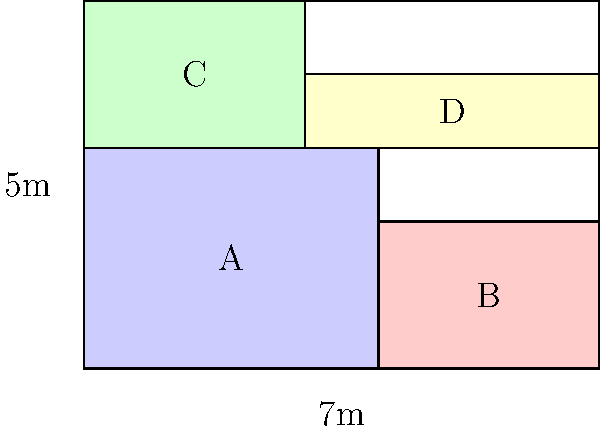Your luxury fashion brand uses high-quality fabric that comes in 7m x 5m rectangles. You need to cut four types of garment pieces: A (4m x 3m), B (3m x 2m), C (3m x 2m), and D (4m x 1m). The profit per piece is €500 for A, €300 for B, €350 for C, and €200 for D. How many pieces of each type should be cut from a single fabric rectangle to maximize profit, and what is the maximum profit? To solve this linear programming problem, we'll follow these steps:

1) Define variables:
   Let $x_A$, $x_B$, $x_C$, and $x_D$ be the number of pieces of each type.

2) Objective function (profit to maximize):
   $P = 500x_A + 300x_B + 350x_C + 200x_D$

3) Constraints:
   a) Area constraint: $12x_A + 6x_B + 6x_C + 4x_D \leq 35$ (total area is 7m x 5m = 35 sq m)
   b) Non-negativity: $x_A, x_B, x_C, x_D \geq 0$ and integers

4) From the diagram, we can see that the maximum possible combinations are:
   - 1A + 1B + 1C + 1D
   - 2A + 1D
   - 1A + 1C + 2D

5) Let's calculate the profit for each combination:
   - 1A + 1B + 1C + 1D: 500 + 300 + 350 + 200 = €1350
   - 2A + 1D: 2(500) + 200 = €1200
   - 1A + 1C + 2D: 500 + 350 + 2(200) = €1250

6) The maximum profit is achieved with the combination 1A + 1B + 1C + 1D, which yields €1350.

Therefore, to maximize profit, you should cut 1 piece each of A, B, C, and D from a single fabric rectangle.
Answer: 1A, 1B, 1C, 1D; €1350 